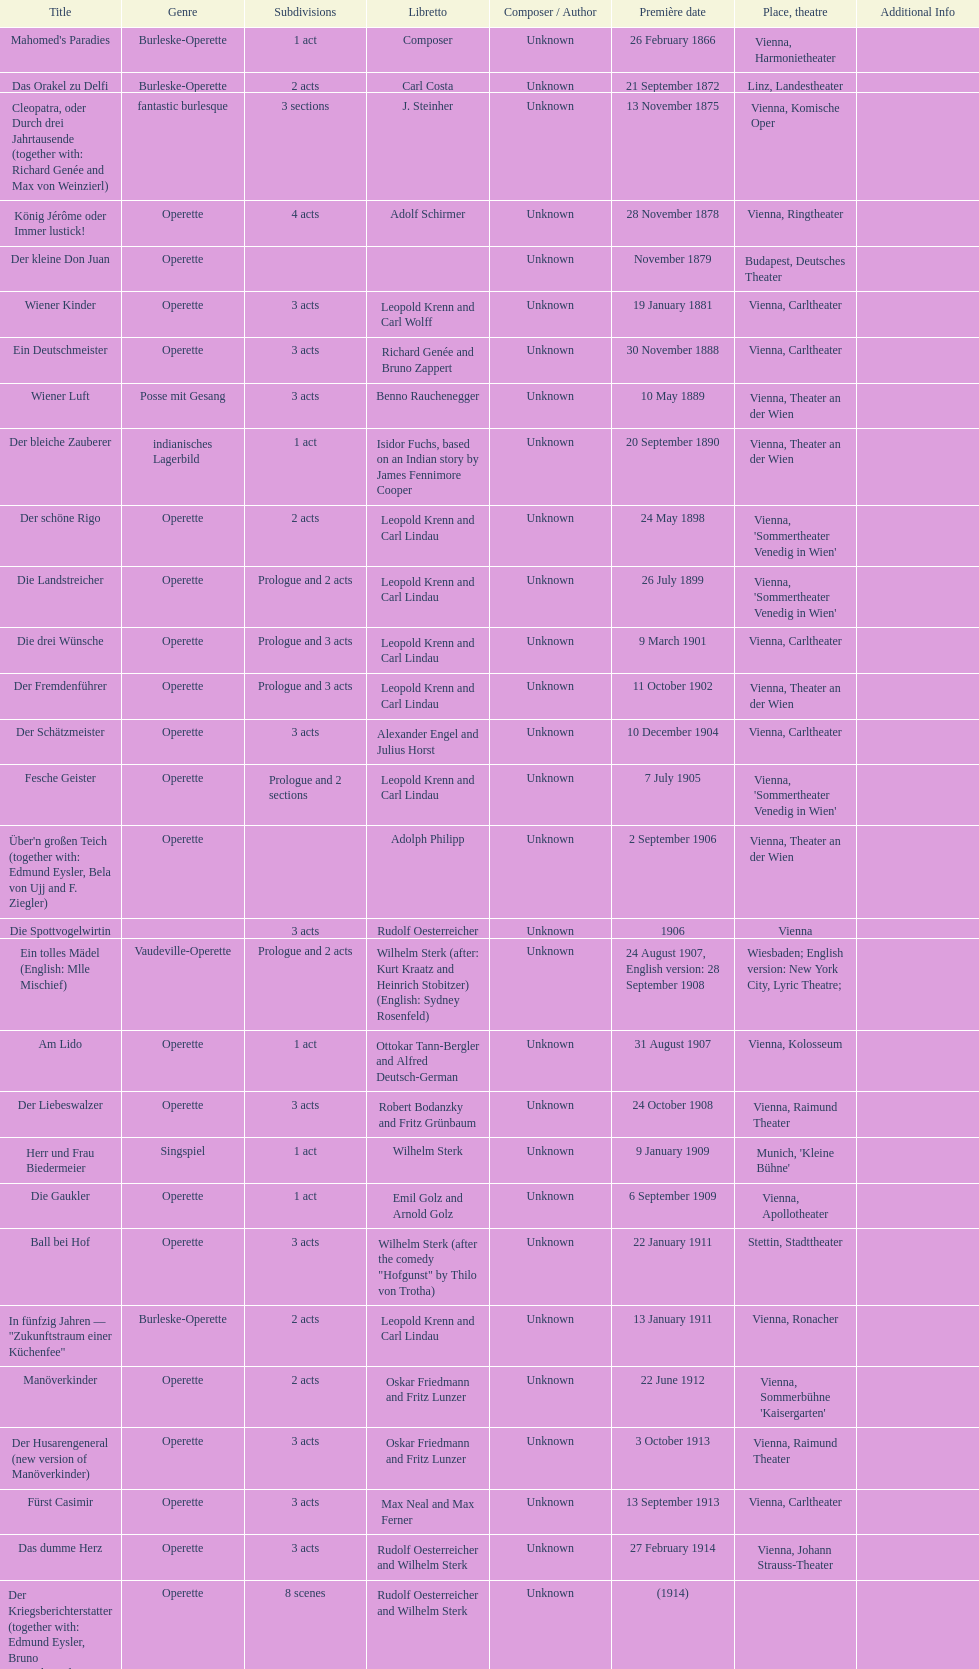Does der liebeswalzer or manöverkinder contain more acts? Der Liebeswalzer. 